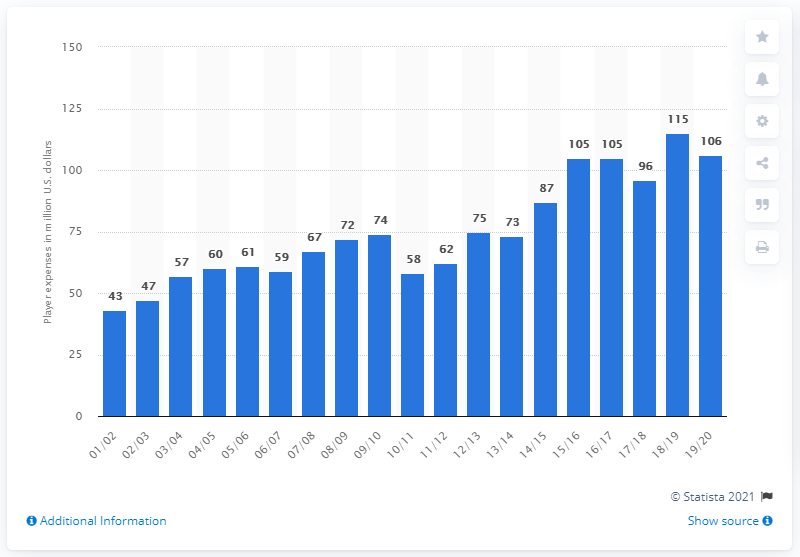Draw attention to some important aspects in this diagram. The player salaries of the Chicago Bulls in the 2019/20 season were $106 million. 